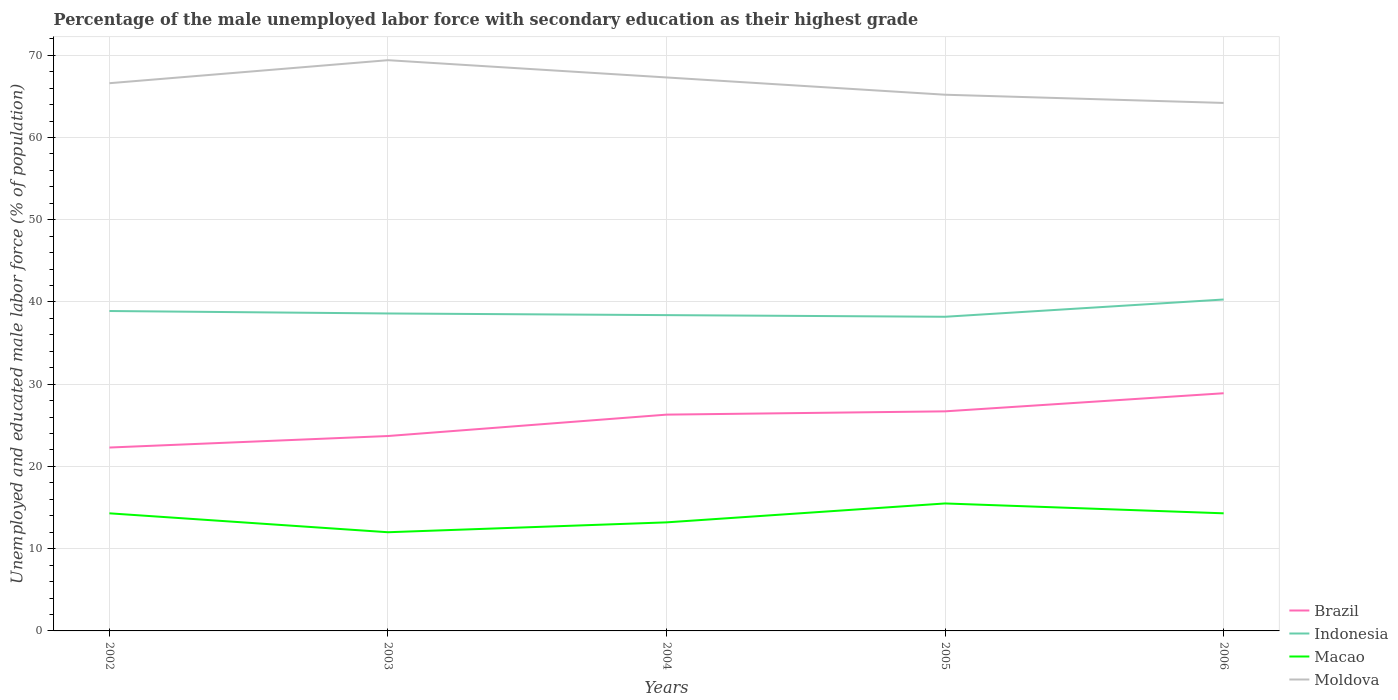How many different coloured lines are there?
Provide a succinct answer. 4. Does the line corresponding to Brazil intersect with the line corresponding to Indonesia?
Offer a very short reply. No. What is the difference between the highest and the second highest percentage of the unemployed male labor force with secondary education in Indonesia?
Your response must be concise. 2.1. What is the difference between the highest and the lowest percentage of the unemployed male labor force with secondary education in Moldova?
Provide a short and direct response. 3. Are the values on the major ticks of Y-axis written in scientific E-notation?
Offer a very short reply. No. Does the graph contain any zero values?
Your response must be concise. No. Does the graph contain grids?
Offer a terse response. Yes. How many legend labels are there?
Provide a succinct answer. 4. What is the title of the graph?
Keep it short and to the point. Percentage of the male unemployed labor force with secondary education as their highest grade. Does "El Salvador" appear as one of the legend labels in the graph?
Make the answer very short. No. What is the label or title of the X-axis?
Provide a short and direct response. Years. What is the label or title of the Y-axis?
Your answer should be very brief. Unemployed and educated male labor force (% of population). What is the Unemployed and educated male labor force (% of population) in Brazil in 2002?
Give a very brief answer. 22.3. What is the Unemployed and educated male labor force (% of population) in Indonesia in 2002?
Give a very brief answer. 38.9. What is the Unemployed and educated male labor force (% of population) of Macao in 2002?
Your answer should be very brief. 14.3. What is the Unemployed and educated male labor force (% of population) in Moldova in 2002?
Keep it short and to the point. 66.6. What is the Unemployed and educated male labor force (% of population) of Brazil in 2003?
Offer a very short reply. 23.7. What is the Unemployed and educated male labor force (% of population) of Indonesia in 2003?
Make the answer very short. 38.6. What is the Unemployed and educated male labor force (% of population) of Moldova in 2003?
Offer a very short reply. 69.4. What is the Unemployed and educated male labor force (% of population) of Brazil in 2004?
Keep it short and to the point. 26.3. What is the Unemployed and educated male labor force (% of population) of Indonesia in 2004?
Provide a succinct answer. 38.4. What is the Unemployed and educated male labor force (% of population) in Macao in 2004?
Offer a terse response. 13.2. What is the Unemployed and educated male labor force (% of population) of Moldova in 2004?
Provide a short and direct response. 67.3. What is the Unemployed and educated male labor force (% of population) in Brazil in 2005?
Give a very brief answer. 26.7. What is the Unemployed and educated male labor force (% of population) of Indonesia in 2005?
Keep it short and to the point. 38.2. What is the Unemployed and educated male labor force (% of population) in Macao in 2005?
Provide a short and direct response. 15.5. What is the Unemployed and educated male labor force (% of population) in Moldova in 2005?
Offer a terse response. 65.2. What is the Unemployed and educated male labor force (% of population) of Brazil in 2006?
Keep it short and to the point. 28.9. What is the Unemployed and educated male labor force (% of population) in Indonesia in 2006?
Your response must be concise. 40.3. What is the Unemployed and educated male labor force (% of population) of Macao in 2006?
Offer a terse response. 14.3. What is the Unemployed and educated male labor force (% of population) of Moldova in 2006?
Your answer should be very brief. 64.2. Across all years, what is the maximum Unemployed and educated male labor force (% of population) in Brazil?
Keep it short and to the point. 28.9. Across all years, what is the maximum Unemployed and educated male labor force (% of population) of Indonesia?
Give a very brief answer. 40.3. Across all years, what is the maximum Unemployed and educated male labor force (% of population) in Moldova?
Offer a terse response. 69.4. Across all years, what is the minimum Unemployed and educated male labor force (% of population) in Brazil?
Provide a short and direct response. 22.3. Across all years, what is the minimum Unemployed and educated male labor force (% of population) of Indonesia?
Provide a succinct answer. 38.2. Across all years, what is the minimum Unemployed and educated male labor force (% of population) in Moldova?
Offer a very short reply. 64.2. What is the total Unemployed and educated male labor force (% of population) of Brazil in the graph?
Provide a short and direct response. 127.9. What is the total Unemployed and educated male labor force (% of population) in Indonesia in the graph?
Offer a terse response. 194.4. What is the total Unemployed and educated male labor force (% of population) of Macao in the graph?
Make the answer very short. 69.3. What is the total Unemployed and educated male labor force (% of population) in Moldova in the graph?
Provide a succinct answer. 332.7. What is the difference between the Unemployed and educated male labor force (% of population) in Indonesia in 2002 and that in 2003?
Keep it short and to the point. 0.3. What is the difference between the Unemployed and educated male labor force (% of population) in Macao in 2002 and that in 2003?
Your response must be concise. 2.3. What is the difference between the Unemployed and educated male labor force (% of population) in Moldova in 2002 and that in 2003?
Your answer should be very brief. -2.8. What is the difference between the Unemployed and educated male labor force (% of population) in Macao in 2002 and that in 2004?
Give a very brief answer. 1.1. What is the difference between the Unemployed and educated male labor force (% of population) in Moldova in 2002 and that in 2004?
Offer a terse response. -0.7. What is the difference between the Unemployed and educated male labor force (% of population) of Indonesia in 2002 and that in 2005?
Offer a terse response. 0.7. What is the difference between the Unemployed and educated male labor force (% of population) in Moldova in 2002 and that in 2005?
Your answer should be compact. 1.4. What is the difference between the Unemployed and educated male labor force (% of population) of Brazil in 2002 and that in 2006?
Provide a short and direct response. -6.6. What is the difference between the Unemployed and educated male labor force (% of population) of Moldova in 2002 and that in 2006?
Offer a terse response. 2.4. What is the difference between the Unemployed and educated male labor force (% of population) of Brazil in 2003 and that in 2004?
Make the answer very short. -2.6. What is the difference between the Unemployed and educated male labor force (% of population) in Indonesia in 2003 and that in 2004?
Offer a terse response. 0.2. What is the difference between the Unemployed and educated male labor force (% of population) of Moldova in 2003 and that in 2005?
Provide a short and direct response. 4.2. What is the difference between the Unemployed and educated male labor force (% of population) of Macao in 2003 and that in 2006?
Ensure brevity in your answer.  -2.3. What is the difference between the Unemployed and educated male labor force (% of population) in Moldova in 2003 and that in 2006?
Provide a succinct answer. 5.2. What is the difference between the Unemployed and educated male labor force (% of population) of Brazil in 2004 and that in 2005?
Keep it short and to the point. -0.4. What is the difference between the Unemployed and educated male labor force (% of population) in Macao in 2004 and that in 2005?
Make the answer very short. -2.3. What is the difference between the Unemployed and educated male labor force (% of population) in Indonesia in 2004 and that in 2006?
Offer a terse response. -1.9. What is the difference between the Unemployed and educated male labor force (% of population) of Macao in 2004 and that in 2006?
Provide a short and direct response. -1.1. What is the difference between the Unemployed and educated male labor force (% of population) in Moldova in 2004 and that in 2006?
Give a very brief answer. 3.1. What is the difference between the Unemployed and educated male labor force (% of population) in Macao in 2005 and that in 2006?
Your answer should be compact. 1.2. What is the difference between the Unemployed and educated male labor force (% of population) in Moldova in 2005 and that in 2006?
Keep it short and to the point. 1. What is the difference between the Unemployed and educated male labor force (% of population) of Brazil in 2002 and the Unemployed and educated male labor force (% of population) of Indonesia in 2003?
Offer a very short reply. -16.3. What is the difference between the Unemployed and educated male labor force (% of population) in Brazil in 2002 and the Unemployed and educated male labor force (% of population) in Moldova in 2003?
Keep it short and to the point. -47.1. What is the difference between the Unemployed and educated male labor force (% of population) of Indonesia in 2002 and the Unemployed and educated male labor force (% of population) of Macao in 2003?
Give a very brief answer. 26.9. What is the difference between the Unemployed and educated male labor force (% of population) in Indonesia in 2002 and the Unemployed and educated male labor force (% of population) in Moldova in 2003?
Offer a terse response. -30.5. What is the difference between the Unemployed and educated male labor force (% of population) in Macao in 2002 and the Unemployed and educated male labor force (% of population) in Moldova in 2003?
Make the answer very short. -55.1. What is the difference between the Unemployed and educated male labor force (% of population) in Brazil in 2002 and the Unemployed and educated male labor force (% of population) in Indonesia in 2004?
Provide a succinct answer. -16.1. What is the difference between the Unemployed and educated male labor force (% of population) in Brazil in 2002 and the Unemployed and educated male labor force (% of population) in Macao in 2004?
Offer a very short reply. 9.1. What is the difference between the Unemployed and educated male labor force (% of population) of Brazil in 2002 and the Unemployed and educated male labor force (% of population) of Moldova in 2004?
Provide a short and direct response. -45. What is the difference between the Unemployed and educated male labor force (% of population) of Indonesia in 2002 and the Unemployed and educated male labor force (% of population) of Macao in 2004?
Your answer should be compact. 25.7. What is the difference between the Unemployed and educated male labor force (% of population) of Indonesia in 2002 and the Unemployed and educated male labor force (% of population) of Moldova in 2004?
Your answer should be very brief. -28.4. What is the difference between the Unemployed and educated male labor force (% of population) in Macao in 2002 and the Unemployed and educated male labor force (% of population) in Moldova in 2004?
Your response must be concise. -53. What is the difference between the Unemployed and educated male labor force (% of population) in Brazil in 2002 and the Unemployed and educated male labor force (% of population) in Indonesia in 2005?
Ensure brevity in your answer.  -15.9. What is the difference between the Unemployed and educated male labor force (% of population) in Brazil in 2002 and the Unemployed and educated male labor force (% of population) in Moldova in 2005?
Make the answer very short. -42.9. What is the difference between the Unemployed and educated male labor force (% of population) of Indonesia in 2002 and the Unemployed and educated male labor force (% of population) of Macao in 2005?
Keep it short and to the point. 23.4. What is the difference between the Unemployed and educated male labor force (% of population) of Indonesia in 2002 and the Unemployed and educated male labor force (% of population) of Moldova in 2005?
Offer a very short reply. -26.3. What is the difference between the Unemployed and educated male labor force (% of population) of Macao in 2002 and the Unemployed and educated male labor force (% of population) of Moldova in 2005?
Your answer should be very brief. -50.9. What is the difference between the Unemployed and educated male labor force (% of population) in Brazil in 2002 and the Unemployed and educated male labor force (% of population) in Macao in 2006?
Offer a very short reply. 8. What is the difference between the Unemployed and educated male labor force (% of population) in Brazil in 2002 and the Unemployed and educated male labor force (% of population) in Moldova in 2006?
Ensure brevity in your answer.  -41.9. What is the difference between the Unemployed and educated male labor force (% of population) in Indonesia in 2002 and the Unemployed and educated male labor force (% of population) in Macao in 2006?
Offer a very short reply. 24.6. What is the difference between the Unemployed and educated male labor force (% of population) in Indonesia in 2002 and the Unemployed and educated male labor force (% of population) in Moldova in 2006?
Make the answer very short. -25.3. What is the difference between the Unemployed and educated male labor force (% of population) of Macao in 2002 and the Unemployed and educated male labor force (% of population) of Moldova in 2006?
Your response must be concise. -49.9. What is the difference between the Unemployed and educated male labor force (% of population) of Brazil in 2003 and the Unemployed and educated male labor force (% of population) of Indonesia in 2004?
Offer a very short reply. -14.7. What is the difference between the Unemployed and educated male labor force (% of population) of Brazil in 2003 and the Unemployed and educated male labor force (% of population) of Macao in 2004?
Provide a short and direct response. 10.5. What is the difference between the Unemployed and educated male labor force (% of population) in Brazil in 2003 and the Unemployed and educated male labor force (% of population) in Moldova in 2004?
Offer a terse response. -43.6. What is the difference between the Unemployed and educated male labor force (% of population) of Indonesia in 2003 and the Unemployed and educated male labor force (% of population) of Macao in 2004?
Your answer should be very brief. 25.4. What is the difference between the Unemployed and educated male labor force (% of population) of Indonesia in 2003 and the Unemployed and educated male labor force (% of population) of Moldova in 2004?
Your response must be concise. -28.7. What is the difference between the Unemployed and educated male labor force (% of population) in Macao in 2003 and the Unemployed and educated male labor force (% of population) in Moldova in 2004?
Offer a very short reply. -55.3. What is the difference between the Unemployed and educated male labor force (% of population) of Brazil in 2003 and the Unemployed and educated male labor force (% of population) of Indonesia in 2005?
Offer a terse response. -14.5. What is the difference between the Unemployed and educated male labor force (% of population) of Brazil in 2003 and the Unemployed and educated male labor force (% of population) of Moldova in 2005?
Keep it short and to the point. -41.5. What is the difference between the Unemployed and educated male labor force (% of population) in Indonesia in 2003 and the Unemployed and educated male labor force (% of population) in Macao in 2005?
Ensure brevity in your answer.  23.1. What is the difference between the Unemployed and educated male labor force (% of population) of Indonesia in 2003 and the Unemployed and educated male labor force (% of population) of Moldova in 2005?
Your answer should be very brief. -26.6. What is the difference between the Unemployed and educated male labor force (% of population) in Macao in 2003 and the Unemployed and educated male labor force (% of population) in Moldova in 2005?
Ensure brevity in your answer.  -53.2. What is the difference between the Unemployed and educated male labor force (% of population) in Brazil in 2003 and the Unemployed and educated male labor force (% of population) in Indonesia in 2006?
Keep it short and to the point. -16.6. What is the difference between the Unemployed and educated male labor force (% of population) of Brazil in 2003 and the Unemployed and educated male labor force (% of population) of Macao in 2006?
Keep it short and to the point. 9.4. What is the difference between the Unemployed and educated male labor force (% of population) in Brazil in 2003 and the Unemployed and educated male labor force (% of population) in Moldova in 2006?
Your answer should be compact. -40.5. What is the difference between the Unemployed and educated male labor force (% of population) of Indonesia in 2003 and the Unemployed and educated male labor force (% of population) of Macao in 2006?
Provide a succinct answer. 24.3. What is the difference between the Unemployed and educated male labor force (% of population) in Indonesia in 2003 and the Unemployed and educated male labor force (% of population) in Moldova in 2006?
Offer a very short reply. -25.6. What is the difference between the Unemployed and educated male labor force (% of population) of Macao in 2003 and the Unemployed and educated male labor force (% of population) of Moldova in 2006?
Offer a terse response. -52.2. What is the difference between the Unemployed and educated male labor force (% of population) of Brazil in 2004 and the Unemployed and educated male labor force (% of population) of Indonesia in 2005?
Keep it short and to the point. -11.9. What is the difference between the Unemployed and educated male labor force (% of population) in Brazil in 2004 and the Unemployed and educated male labor force (% of population) in Moldova in 2005?
Provide a succinct answer. -38.9. What is the difference between the Unemployed and educated male labor force (% of population) in Indonesia in 2004 and the Unemployed and educated male labor force (% of population) in Macao in 2005?
Offer a very short reply. 22.9. What is the difference between the Unemployed and educated male labor force (% of population) in Indonesia in 2004 and the Unemployed and educated male labor force (% of population) in Moldova in 2005?
Your response must be concise. -26.8. What is the difference between the Unemployed and educated male labor force (% of population) of Macao in 2004 and the Unemployed and educated male labor force (% of population) of Moldova in 2005?
Give a very brief answer. -52. What is the difference between the Unemployed and educated male labor force (% of population) in Brazil in 2004 and the Unemployed and educated male labor force (% of population) in Macao in 2006?
Ensure brevity in your answer.  12. What is the difference between the Unemployed and educated male labor force (% of population) of Brazil in 2004 and the Unemployed and educated male labor force (% of population) of Moldova in 2006?
Ensure brevity in your answer.  -37.9. What is the difference between the Unemployed and educated male labor force (% of population) of Indonesia in 2004 and the Unemployed and educated male labor force (% of population) of Macao in 2006?
Provide a succinct answer. 24.1. What is the difference between the Unemployed and educated male labor force (% of population) in Indonesia in 2004 and the Unemployed and educated male labor force (% of population) in Moldova in 2006?
Offer a terse response. -25.8. What is the difference between the Unemployed and educated male labor force (% of population) in Macao in 2004 and the Unemployed and educated male labor force (% of population) in Moldova in 2006?
Your answer should be very brief. -51. What is the difference between the Unemployed and educated male labor force (% of population) in Brazil in 2005 and the Unemployed and educated male labor force (% of population) in Indonesia in 2006?
Ensure brevity in your answer.  -13.6. What is the difference between the Unemployed and educated male labor force (% of population) in Brazil in 2005 and the Unemployed and educated male labor force (% of population) in Macao in 2006?
Keep it short and to the point. 12.4. What is the difference between the Unemployed and educated male labor force (% of population) of Brazil in 2005 and the Unemployed and educated male labor force (% of population) of Moldova in 2006?
Make the answer very short. -37.5. What is the difference between the Unemployed and educated male labor force (% of population) of Indonesia in 2005 and the Unemployed and educated male labor force (% of population) of Macao in 2006?
Offer a very short reply. 23.9. What is the difference between the Unemployed and educated male labor force (% of population) in Macao in 2005 and the Unemployed and educated male labor force (% of population) in Moldova in 2006?
Give a very brief answer. -48.7. What is the average Unemployed and educated male labor force (% of population) of Brazil per year?
Keep it short and to the point. 25.58. What is the average Unemployed and educated male labor force (% of population) of Indonesia per year?
Your answer should be very brief. 38.88. What is the average Unemployed and educated male labor force (% of population) in Macao per year?
Offer a very short reply. 13.86. What is the average Unemployed and educated male labor force (% of population) of Moldova per year?
Your answer should be very brief. 66.54. In the year 2002, what is the difference between the Unemployed and educated male labor force (% of population) of Brazil and Unemployed and educated male labor force (% of population) of Indonesia?
Offer a terse response. -16.6. In the year 2002, what is the difference between the Unemployed and educated male labor force (% of population) in Brazil and Unemployed and educated male labor force (% of population) in Macao?
Give a very brief answer. 8. In the year 2002, what is the difference between the Unemployed and educated male labor force (% of population) of Brazil and Unemployed and educated male labor force (% of population) of Moldova?
Provide a short and direct response. -44.3. In the year 2002, what is the difference between the Unemployed and educated male labor force (% of population) of Indonesia and Unemployed and educated male labor force (% of population) of Macao?
Your answer should be compact. 24.6. In the year 2002, what is the difference between the Unemployed and educated male labor force (% of population) in Indonesia and Unemployed and educated male labor force (% of population) in Moldova?
Your response must be concise. -27.7. In the year 2002, what is the difference between the Unemployed and educated male labor force (% of population) of Macao and Unemployed and educated male labor force (% of population) of Moldova?
Your response must be concise. -52.3. In the year 2003, what is the difference between the Unemployed and educated male labor force (% of population) in Brazil and Unemployed and educated male labor force (% of population) in Indonesia?
Your response must be concise. -14.9. In the year 2003, what is the difference between the Unemployed and educated male labor force (% of population) in Brazil and Unemployed and educated male labor force (% of population) in Moldova?
Offer a terse response. -45.7. In the year 2003, what is the difference between the Unemployed and educated male labor force (% of population) in Indonesia and Unemployed and educated male labor force (% of population) in Macao?
Make the answer very short. 26.6. In the year 2003, what is the difference between the Unemployed and educated male labor force (% of population) in Indonesia and Unemployed and educated male labor force (% of population) in Moldova?
Your answer should be very brief. -30.8. In the year 2003, what is the difference between the Unemployed and educated male labor force (% of population) of Macao and Unemployed and educated male labor force (% of population) of Moldova?
Make the answer very short. -57.4. In the year 2004, what is the difference between the Unemployed and educated male labor force (% of population) of Brazil and Unemployed and educated male labor force (% of population) of Indonesia?
Your response must be concise. -12.1. In the year 2004, what is the difference between the Unemployed and educated male labor force (% of population) in Brazil and Unemployed and educated male labor force (% of population) in Macao?
Provide a succinct answer. 13.1. In the year 2004, what is the difference between the Unemployed and educated male labor force (% of population) of Brazil and Unemployed and educated male labor force (% of population) of Moldova?
Keep it short and to the point. -41. In the year 2004, what is the difference between the Unemployed and educated male labor force (% of population) in Indonesia and Unemployed and educated male labor force (% of population) in Macao?
Provide a short and direct response. 25.2. In the year 2004, what is the difference between the Unemployed and educated male labor force (% of population) in Indonesia and Unemployed and educated male labor force (% of population) in Moldova?
Your answer should be compact. -28.9. In the year 2004, what is the difference between the Unemployed and educated male labor force (% of population) of Macao and Unemployed and educated male labor force (% of population) of Moldova?
Your answer should be very brief. -54.1. In the year 2005, what is the difference between the Unemployed and educated male labor force (% of population) of Brazil and Unemployed and educated male labor force (% of population) of Macao?
Provide a succinct answer. 11.2. In the year 2005, what is the difference between the Unemployed and educated male labor force (% of population) in Brazil and Unemployed and educated male labor force (% of population) in Moldova?
Make the answer very short. -38.5. In the year 2005, what is the difference between the Unemployed and educated male labor force (% of population) in Indonesia and Unemployed and educated male labor force (% of population) in Macao?
Provide a short and direct response. 22.7. In the year 2005, what is the difference between the Unemployed and educated male labor force (% of population) in Macao and Unemployed and educated male labor force (% of population) in Moldova?
Your response must be concise. -49.7. In the year 2006, what is the difference between the Unemployed and educated male labor force (% of population) in Brazil and Unemployed and educated male labor force (% of population) in Indonesia?
Make the answer very short. -11.4. In the year 2006, what is the difference between the Unemployed and educated male labor force (% of population) of Brazil and Unemployed and educated male labor force (% of population) of Macao?
Provide a short and direct response. 14.6. In the year 2006, what is the difference between the Unemployed and educated male labor force (% of population) in Brazil and Unemployed and educated male labor force (% of population) in Moldova?
Make the answer very short. -35.3. In the year 2006, what is the difference between the Unemployed and educated male labor force (% of population) in Indonesia and Unemployed and educated male labor force (% of population) in Moldova?
Your answer should be very brief. -23.9. In the year 2006, what is the difference between the Unemployed and educated male labor force (% of population) of Macao and Unemployed and educated male labor force (% of population) of Moldova?
Provide a succinct answer. -49.9. What is the ratio of the Unemployed and educated male labor force (% of population) in Brazil in 2002 to that in 2003?
Provide a short and direct response. 0.94. What is the ratio of the Unemployed and educated male labor force (% of population) of Macao in 2002 to that in 2003?
Keep it short and to the point. 1.19. What is the ratio of the Unemployed and educated male labor force (% of population) in Moldova in 2002 to that in 2003?
Give a very brief answer. 0.96. What is the ratio of the Unemployed and educated male labor force (% of population) in Brazil in 2002 to that in 2004?
Your answer should be very brief. 0.85. What is the ratio of the Unemployed and educated male labor force (% of population) of Macao in 2002 to that in 2004?
Make the answer very short. 1.08. What is the ratio of the Unemployed and educated male labor force (% of population) of Brazil in 2002 to that in 2005?
Your answer should be compact. 0.84. What is the ratio of the Unemployed and educated male labor force (% of population) of Indonesia in 2002 to that in 2005?
Your answer should be compact. 1.02. What is the ratio of the Unemployed and educated male labor force (% of population) in Macao in 2002 to that in 2005?
Offer a very short reply. 0.92. What is the ratio of the Unemployed and educated male labor force (% of population) of Moldova in 2002 to that in 2005?
Offer a very short reply. 1.02. What is the ratio of the Unemployed and educated male labor force (% of population) in Brazil in 2002 to that in 2006?
Provide a short and direct response. 0.77. What is the ratio of the Unemployed and educated male labor force (% of population) of Indonesia in 2002 to that in 2006?
Make the answer very short. 0.97. What is the ratio of the Unemployed and educated male labor force (% of population) of Macao in 2002 to that in 2006?
Give a very brief answer. 1. What is the ratio of the Unemployed and educated male labor force (% of population) of Moldova in 2002 to that in 2006?
Keep it short and to the point. 1.04. What is the ratio of the Unemployed and educated male labor force (% of population) in Brazil in 2003 to that in 2004?
Your answer should be compact. 0.9. What is the ratio of the Unemployed and educated male labor force (% of population) of Indonesia in 2003 to that in 2004?
Provide a short and direct response. 1.01. What is the ratio of the Unemployed and educated male labor force (% of population) of Macao in 2003 to that in 2004?
Make the answer very short. 0.91. What is the ratio of the Unemployed and educated male labor force (% of population) of Moldova in 2003 to that in 2004?
Give a very brief answer. 1.03. What is the ratio of the Unemployed and educated male labor force (% of population) in Brazil in 2003 to that in 2005?
Provide a succinct answer. 0.89. What is the ratio of the Unemployed and educated male labor force (% of population) of Indonesia in 2003 to that in 2005?
Make the answer very short. 1.01. What is the ratio of the Unemployed and educated male labor force (% of population) in Macao in 2003 to that in 2005?
Your answer should be compact. 0.77. What is the ratio of the Unemployed and educated male labor force (% of population) of Moldova in 2003 to that in 2005?
Your response must be concise. 1.06. What is the ratio of the Unemployed and educated male labor force (% of population) in Brazil in 2003 to that in 2006?
Your answer should be very brief. 0.82. What is the ratio of the Unemployed and educated male labor force (% of population) of Indonesia in 2003 to that in 2006?
Offer a terse response. 0.96. What is the ratio of the Unemployed and educated male labor force (% of population) of Macao in 2003 to that in 2006?
Keep it short and to the point. 0.84. What is the ratio of the Unemployed and educated male labor force (% of population) in Moldova in 2003 to that in 2006?
Your answer should be very brief. 1.08. What is the ratio of the Unemployed and educated male labor force (% of population) in Indonesia in 2004 to that in 2005?
Offer a terse response. 1.01. What is the ratio of the Unemployed and educated male labor force (% of population) in Macao in 2004 to that in 2005?
Provide a short and direct response. 0.85. What is the ratio of the Unemployed and educated male labor force (% of population) of Moldova in 2004 to that in 2005?
Your answer should be very brief. 1.03. What is the ratio of the Unemployed and educated male labor force (% of population) of Brazil in 2004 to that in 2006?
Give a very brief answer. 0.91. What is the ratio of the Unemployed and educated male labor force (% of population) in Indonesia in 2004 to that in 2006?
Your response must be concise. 0.95. What is the ratio of the Unemployed and educated male labor force (% of population) in Moldova in 2004 to that in 2006?
Ensure brevity in your answer.  1.05. What is the ratio of the Unemployed and educated male labor force (% of population) in Brazil in 2005 to that in 2006?
Provide a succinct answer. 0.92. What is the ratio of the Unemployed and educated male labor force (% of population) of Indonesia in 2005 to that in 2006?
Provide a short and direct response. 0.95. What is the ratio of the Unemployed and educated male labor force (% of population) in Macao in 2005 to that in 2006?
Keep it short and to the point. 1.08. What is the ratio of the Unemployed and educated male labor force (% of population) of Moldova in 2005 to that in 2006?
Keep it short and to the point. 1.02. What is the difference between the highest and the second highest Unemployed and educated male labor force (% of population) in Indonesia?
Give a very brief answer. 1.4. What is the difference between the highest and the lowest Unemployed and educated male labor force (% of population) of Moldova?
Provide a succinct answer. 5.2. 